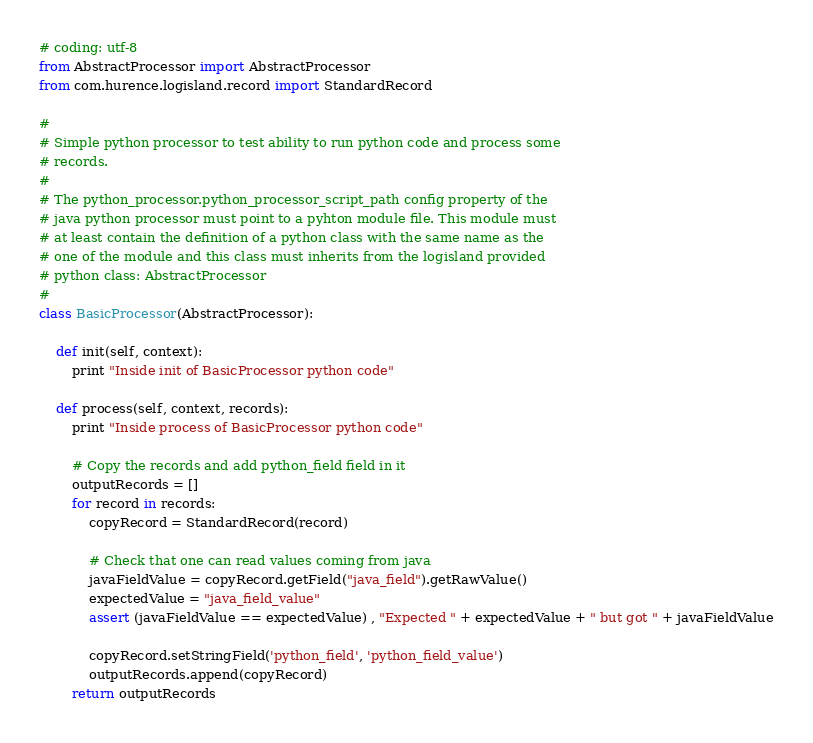<code> <loc_0><loc_0><loc_500><loc_500><_Python_># coding: utf-8
from AbstractProcessor import AbstractProcessor
from com.hurence.logisland.record import StandardRecord

#
# Simple python processor to test ability to run python code and process some
# records.
# 
# The python_processor.python_processor_script_path config property of the
# java python processor must point to a pyhton module file. This module must
# at least contain the definition of a python class with the same name as the
# one of the module and this class must inherits from the logisland provided
# python class: AbstractProcessor
#
class BasicProcessor(AbstractProcessor):

    def init(self, context):
        print "Inside init of BasicProcessor python code"
  
    def process(self, context, records):
        print "Inside process of BasicProcessor python code"

        # Copy the records and add python_field field in it
        outputRecords = []
        for record in records:
            copyRecord = StandardRecord(record)

            # Check that one can read values coming from java
            javaFieldValue = copyRecord.getField("java_field").getRawValue()
            expectedValue = "java_field_value"
            assert (javaFieldValue == expectedValue) , "Expected " + expectedValue + " but got " + javaFieldValue

            copyRecord.setStringField('python_field', 'python_field_value')
            outputRecords.append(copyRecord)
        return outputRecords</code> 